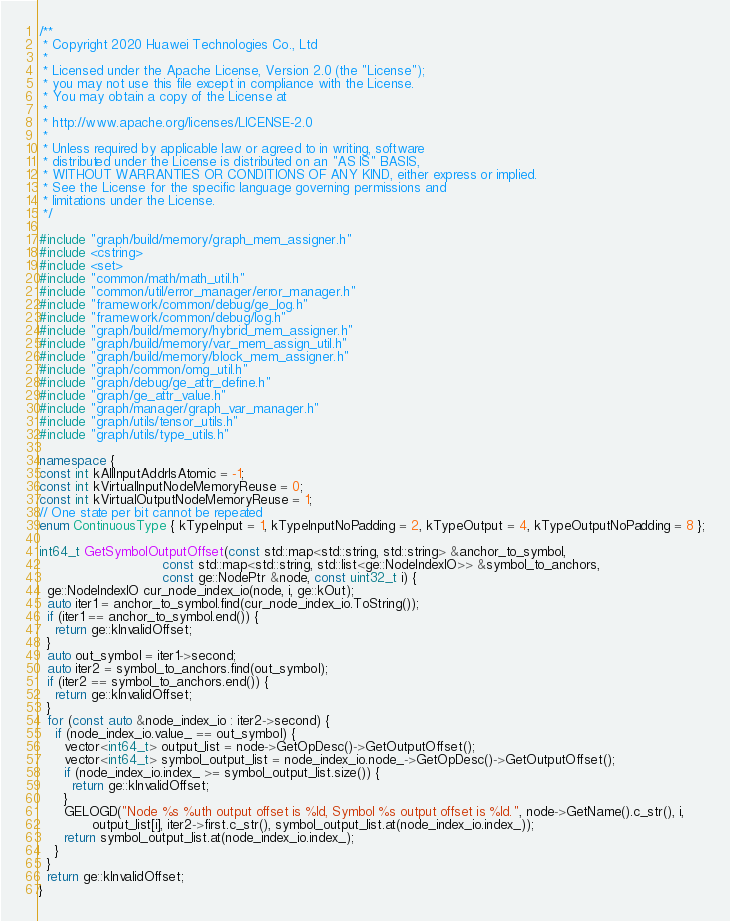Convert code to text. <code><loc_0><loc_0><loc_500><loc_500><_C++_>/**
 * Copyright 2020 Huawei Technologies Co., Ltd
 *
 * Licensed under the Apache License, Version 2.0 (the "License");
 * you may not use this file except in compliance with the License.
 * You may obtain a copy of the License at
 *
 * http://www.apache.org/licenses/LICENSE-2.0
 *
 * Unless required by applicable law or agreed to in writing, software
 * distributed under the License is distributed on an "AS IS" BASIS,
 * WITHOUT WARRANTIES OR CONDITIONS OF ANY KIND, either express or implied.
 * See the License for the specific language governing permissions and
 * limitations under the License.
 */

#include "graph/build/memory/graph_mem_assigner.h"
#include <cstring>
#include <set>
#include "common/math/math_util.h"
#include "common/util/error_manager/error_manager.h"
#include "framework/common/debug/ge_log.h"
#include "framework/common/debug/log.h"
#include "graph/build/memory/hybrid_mem_assigner.h"
#include "graph/build/memory/var_mem_assign_util.h"
#include "graph/build/memory/block_mem_assigner.h"
#include "graph/common/omg_util.h"
#include "graph/debug/ge_attr_define.h"
#include "graph/ge_attr_value.h"
#include "graph/manager/graph_var_manager.h"
#include "graph/utils/tensor_utils.h"
#include "graph/utils/type_utils.h"

namespace {
const int kAllInputAddrIsAtomic = -1;
const int kVirtualInputNodeMemoryReuse = 0;
const int kVirtualOutputNodeMemoryReuse = 1;
// One state per bit cannot be repeated
enum ContinuousType { kTypeInput = 1, kTypeInputNoPadding = 2, kTypeOutput = 4, kTypeOutputNoPadding = 8 };

int64_t GetSymbolOutputOffset(const std::map<std::string, std::string> &anchor_to_symbol,
                              const std::map<std::string, std::list<ge::NodeIndexIO>> &symbol_to_anchors,
                              const ge::NodePtr &node, const uint32_t i) {
  ge::NodeIndexIO cur_node_index_io(node, i, ge::kOut);
  auto iter1 = anchor_to_symbol.find(cur_node_index_io.ToString());
  if (iter1 == anchor_to_symbol.end()) {
    return ge::kInvalidOffset;
  }
  auto out_symbol = iter1->second;
  auto iter2 = symbol_to_anchors.find(out_symbol);
  if (iter2 == symbol_to_anchors.end()) {
    return ge::kInvalidOffset;
  }
  for (const auto &node_index_io : iter2->second) {
    if (node_index_io.value_ == out_symbol) {
      vector<int64_t> output_list = node->GetOpDesc()->GetOutputOffset();
      vector<int64_t> symbol_output_list = node_index_io.node_->GetOpDesc()->GetOutputOffset();
      if (node_index_io.index_ >= symbol_output_list.size()) {
        return ge::kInvalidOffset;
      }
      GELOGD("Node %s %uth output offset is %ld, Symbol %s output offset is %ld.", node->GetName().c_str(), i,
             output_list[i], iter2->first.c_str(), symbol_output_list.at(node_index_io.index_));
      return symbol_output_list.at(node_index_io.index_);
    }
  }
  return ge::kInvalidOffset;
}</code> 